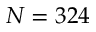Convert formula to latex. <formula><loc_0><loc_0><loc_500><loc_500>N = 3 2 4</formula> 